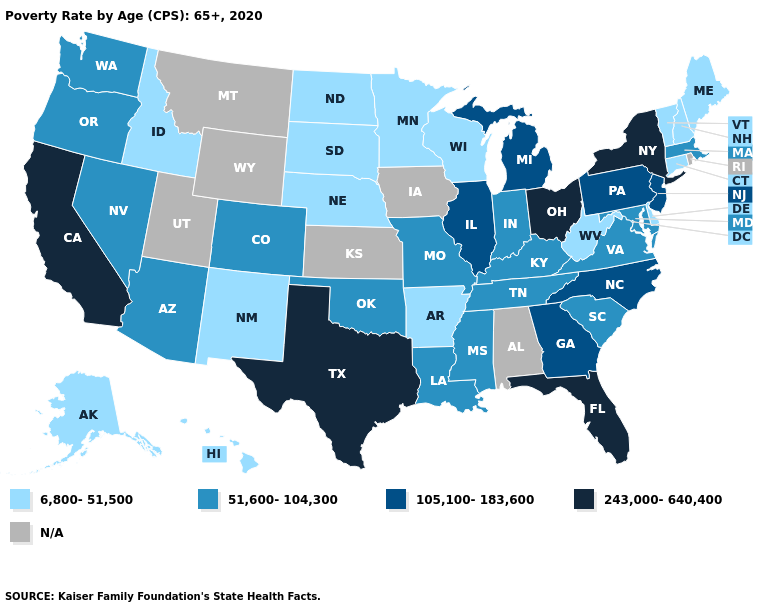What is the value of Vermont?
Short answer required. 6,800-51,500. What is the lowest value in the South?
Quick response, please. 6,800-51,500. Name the states that have a value in the range 105,100-183,600?
Answer briefly. Georgia, Illinois, Michigan, New Jersey, North Carolina, Pennsylvania. What is the lowest value in states that border Alabama?
Give a very brief answer. 51,600-104,300. Is the legend a continuous bar?
Answer briefly. No. What is the highest value in states that border Missouri?
Answer briefly. 105,100-183,600. What is the value of Vermont?
Short answer required. 6,800-51,500. What is the highest value in the West ?
Be succinct. 243,000-640,400. Does Kentucky have the highest value in the USA?
Answer briefly. No. Name the states that have a value in the range 243,000-640,400?
Concise answer only. California, Florida, New York, Ohio, Texas. Name the states that have a value in the range N/A?
Write a very short answer. Alabama, Iowa, Kansas, Montana, Rhode Island, Utah, Wyoming. What is the highest value in states that border Pennsylvania?
Keep it brief. 243,000-640,400. What is the value of Louisiana?
Quick response, please. 51,600-104,300. Does New York have the highest value in the USA?
Write a very short answer. Yes. Does California have the highest value in the USA?
Short answer required. Yes. 